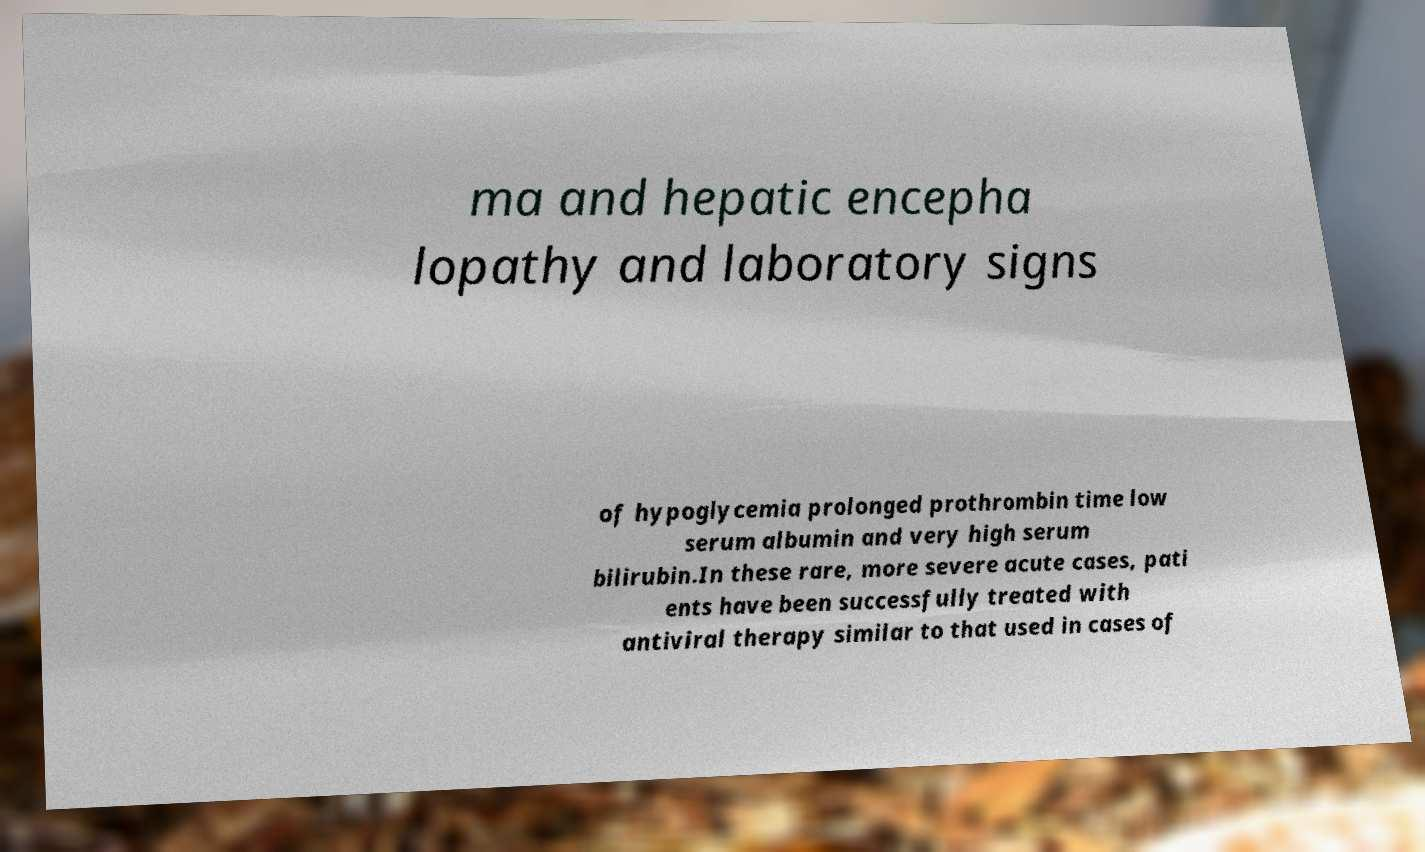For documentation purposes, I need the text within this image transcribed. Could you provide that? ma and hepatic encepha lopathy and laboratory signs of hypoglycemia prolonged prothrombin time low serum albumin and very high serum bilirubin.In these rare, more severe acute cases, pati ents have been successfully treated with antiviral therapy similar to that used in cases of 